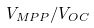Convert formula to latex. <formula><loc_0><loc_0><loc_500><loc_500>V _ { M P P } / V _ { O C }</formula> 